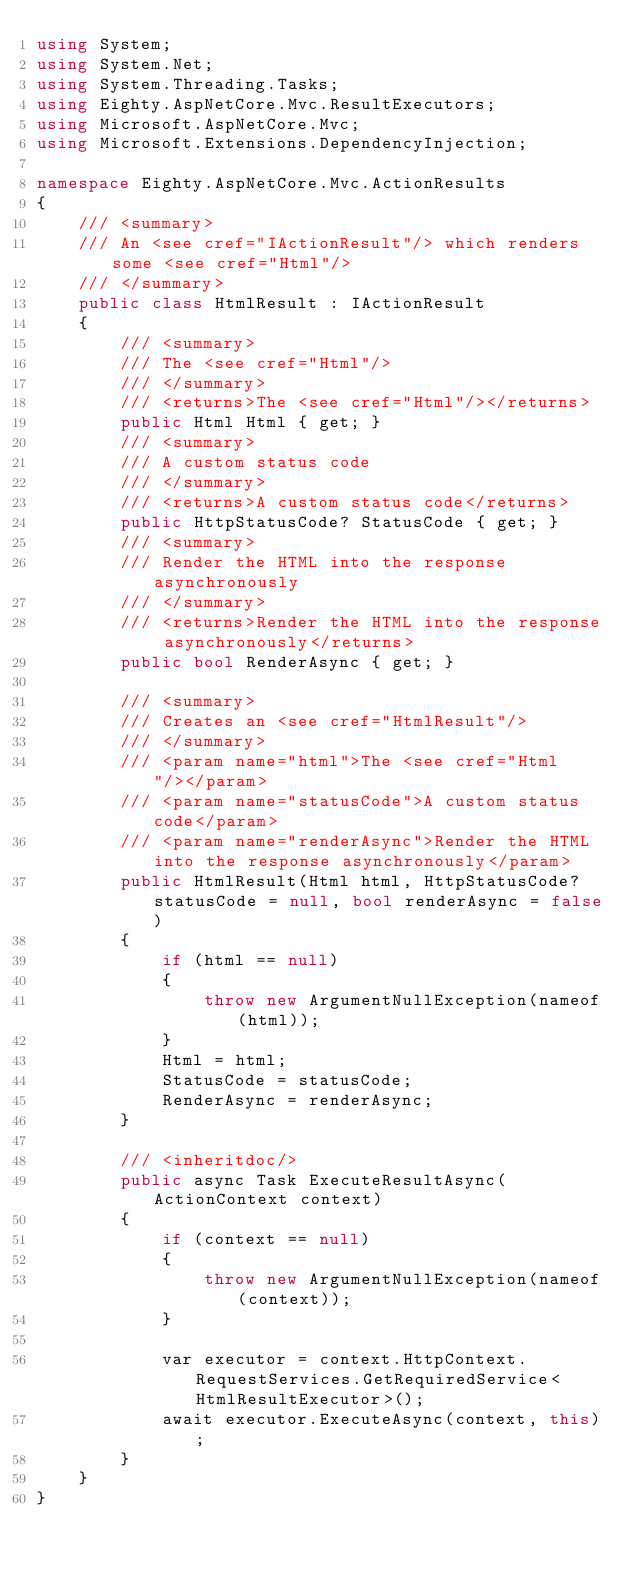Convert code to text. <code><loc_0><loc_0><loc_500><loc_500><_C#_>using System;
using System.Net;
using System.Threading.Tasks;
using Eighty.AspNetCore.Mvc.ResultExecutors;
using Microsoft.AspNetCore.Mvc;
using Microsoft.Extensions.DependencyInjection;

namespace Eighty.AspNetCore.Mvc.ActionResults
{
    /// <summary>
    /// An <see cref="IActionResult"/> which renders some <see cref="Html"/>
    /// </summary>
    public class HtmlResult : IActionResult
    {
        /// <summary>
        /// The <see cref="Html"/>
        /// </summary>
        /// <returns>The <see cref="Html"/></returns>
        public Html Html { get; }
        /// <summary>
        /// A custom status code
        /// </summary>
        /// <returns>A custom status code</returns>
        public HttpStatusCode? StatusCode { get; }
        /// <summary>
        /// Render the HTML into the response asynchronously
        /// </summary>
        /// <returns>Render the HTML into the response asynchronously</returns>
        public bool RenderAsync { get; }

        /// <summary>
        /// Creates an <see cref="HtmlResult"/>
        /// </summary>
        /// <param name="html">The <see cref="Html"/></param>
        /// <param name="statusCode">A custom status code</param>
        /// <param name="renderAsync">Render the HTML into the response asynchronously</param>
        public HtmlResult(Html html, HttpStatusCode? statusCode = null, bool renderAsync = false)
        {
            if (html == null)
            {
                throw new ArgumentNullException(nameof(html));
            }
            Html = html;
            StatusCode = statusCode;
            RenderAsync = renderAsync;
        }

        /// <inheritdoc/>
        public async Task ExecuteResultAsync(ActionContext context)
        {
            if (context == null)
            {
                throw new ArgumentNullException(nameof(context));
            }

            var executor = context.HttpContext.RequestServices.GetRequiredService<HtmlResultExecutor>();
            await executor.ExecuteAsync(context, this);
        }
    }
}</code> 